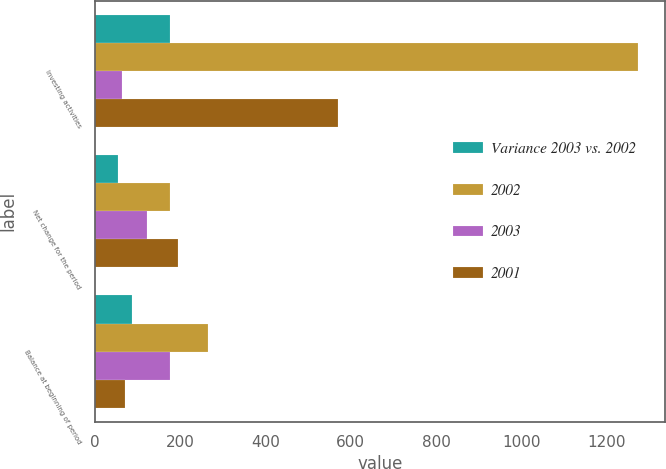Convert chart. <chart><loc_0><loc_0><loc_500><loc_500><stacked_bar_chart><ecel><fcel>Investing activities<fcel>Net change for the period<fcel>Balance at beginning of period<nl><fcel>Variance 2003 vs. 2002<fcel>177<fcel>55<fcel>88<nl><fcel>2002<fcel>1273<fcel>177<fcel>265<nl><fcel>2003<fcel>64<fcel>122<fcel>177<nl><fcel>2001<fcel>569<fcel>195<fcel>70<nl></chart> 